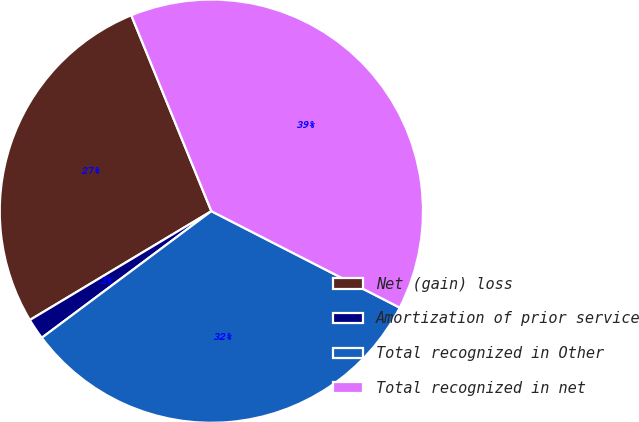<chart> <loc_0><loc_0><loc_500><loc_500><pie_chart><fcel>Net (gain) loss<fcel>Amortization of prior service<fcel>Total recognized in Other<fcel>Total recognized in net<nl><fcel>27.42%<fcel>1.61%<fcel>32.26%<fcel>38.71%<nl></chart> 